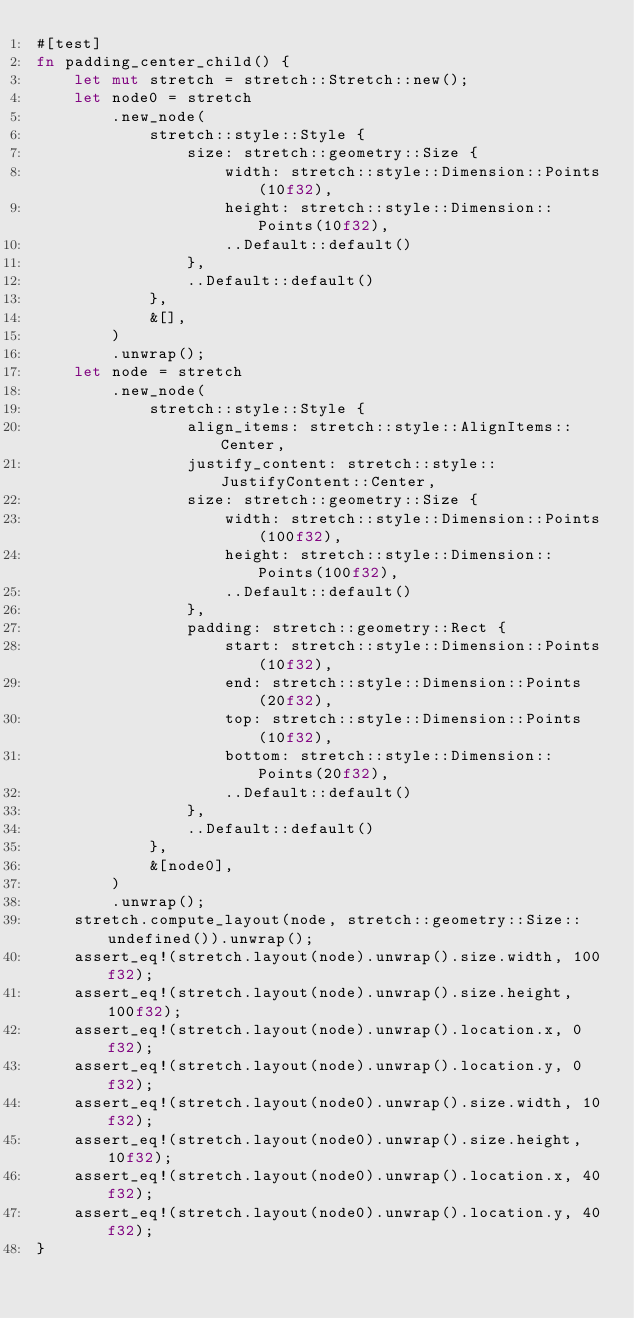Convert code to text. <code><loc_0><loc_0><loc_500><loc_500><_Rust_>#[test]
fn padding_center_child() {
    let mut stretch = stretch::Stretch::new();
    let node0 = stretch
        .new_node(
            stretch::style::Style {
                size: stretch::geometry::Size {
                    width: stretch::style::Dimension::Points(10f32),
                    height: stretch::style::Dimension::Points(10f32),
                    ..Default::default()
                },
                ..Default::default()
            },
            &[],
        )
        .unwrap();
    let node = stretch
        .new_node(
            stretch::style::Style {
                align_items: stretch::style::AlignItems::Center,
                justify_content: stretch::style::JustifyContent::Center,
                size: stretch::geometry::Size {
                    width: stretch::style::Dimension::Points(100f32),
                    height: stretch::style::Dimension::Points(100f32),
                    ..Default::default()
                },
                padding: stretch::geometry::Rect {
                    start: stretch::style::Dimension::Points(10f32),
                    end: stretch::style::Dimension::Points(20f32),
                    top: stretch::style::Dimension::Points(10f32),
                    bottom: stretch::style::Dimension::Points(20f32),
                    ..Default::default()
                },
                ..Default::default()
            },
            &[node0],
        )
        .unwrap();
    stretch.compute_layout(node, stretch::geometry::Size::undefined()).unwrap();
    assert_eq!(stretch.layout(node).unwrap().size.width, 100f32);
    assert_eq!(stretch.layout(node).unwrap().size.height, 100f32);
    assert_eq!(stretch.layout(node).unwrap().location.x, 0f32);
    assert_eq!(stretch.layout(node).unwrap().location.y, 0f32);
    assert_eq!(stretch.layout(node0).unwrap().size.width, 10f32);
    assert_eq!(stretch.layout(node0).unwrap().size.height, 10f32);
    assert_eq!(stretch.layout(node0).unwrap().location.x, 40f32);
    assert_eq!(stretch.layout(node0).unwrap().location.y, 40f32);
}
</code> 